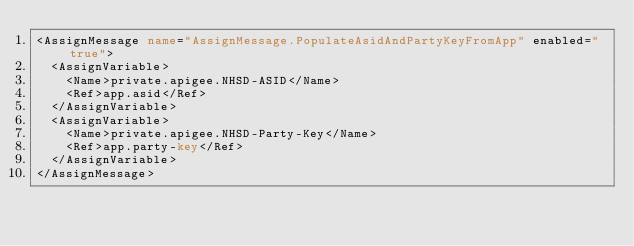Convert code to text. <code><loc_0><loc_0><loc_500><loc_500><_XML_><AssignMessage name="AssignMessage.PopulateAsidAndPartyKeyFromApp" enabled="true">
  <AssignVariable>
    <Name>private.apigee.NHSD-ASID</Name>
    <Ref>app.asid</Ref>
  </AssignVariable>
  <AssignVariable>
    <Name>private.apigee.NHSD-Party-Key</Name>
    <Ref>app.party-key</Ref>
  </AssignVariable>
</AssignMessage>
</code> 